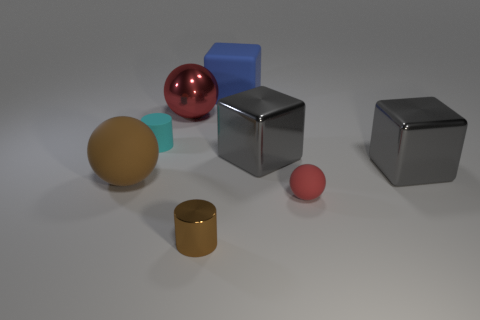What color is the small matte cylinder?
Make the answer very short. Cyan. Do the tiny matte object to the right of the tiny cyan object and the big matte thing on the right side of the brown cylinder have the same shape?
Your response must be concise. No. There is a small cylinder that is behind the metallic cylinder; what is its color?
Keep it short and to the point. Cyan. Is the number of large red objects on the right side of the matte block less than the number of red things right of the large red shiny ball?
Make the answer very short. Yes. How many other things are made of the same material as the small brown cylinder?
Give a very brief answer. 3. Does the cyan cylinder have the same material as the tiny red object?
Make the answer very short. Yes. What number of other things are there of the same size as the cyan rubber thing?
Keep it short and to the point. 2. Are there an equal number of red shiny spheres and big gray metal objects?
Give a very brief answer. No. There is a red sphere to the left of the tiny matte thing that is in front of the large brown matte thing; what is its size?
Provide a succinct answer. Large. The metallic thing behind the big shiny cube to the left of the small object that is on the right side of the blue matte object is what color?
Offer a very short reply. Red. 